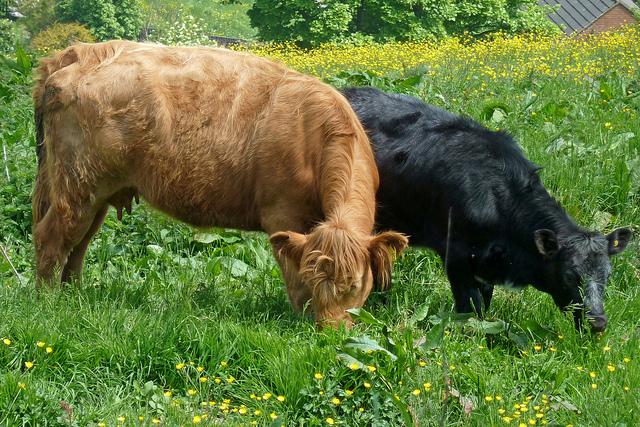Do these animals have tags?
Quick response, please. No. Would it be bad to antagonize the cows?
Quick response, please. Yes. Are they eating?
Write a very short answer. Yes. Is the brown animal a female?
Short answer required. Yes. Does this animal have horns?
Give a very brief answer. No. How many animals are eating?
Be succinct. 2. Are the cows related?
Give a very brief answer. No. What is this animal doing?
Concise answer only. Eating. Where are the yellow flowers?
Give a very brief answer. Dandelions. Are all the cows eating grass?
Concise answer only. Yes. What is the cow eating?
Be succinct. Grass. 